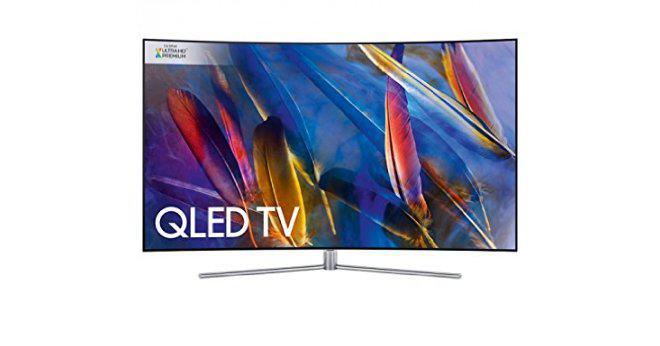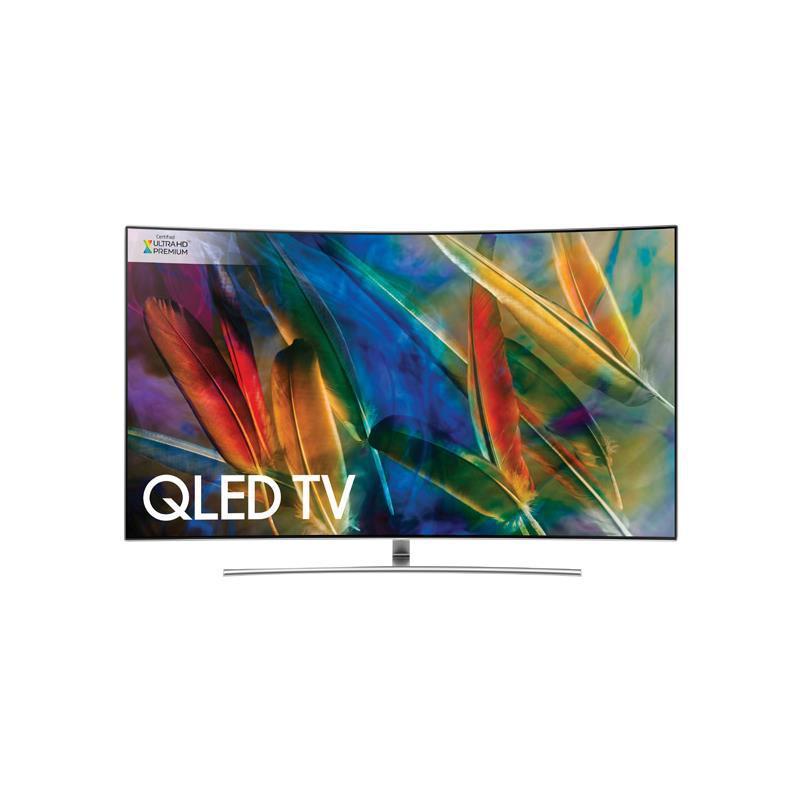The first image is the image on the left, the second image is the image on the right. Evaluate the accuracy of this statement regarding the images: "Atleast one tv has an image of something alive.". Is it true? Answer yes or no. No. 